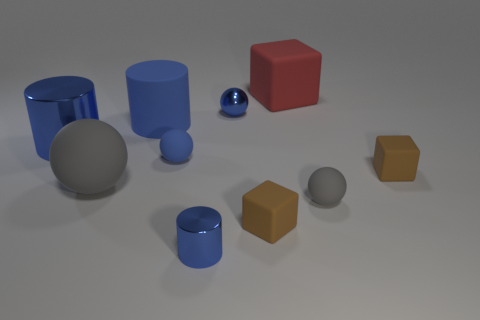Subtract all blue metallic cylinders. How many cylinders are left? 1 Subtract all gray spheres. How many spheres are left? 2 Subtract all yellow cylinders. Subtract all cyan cubes. How many cylinders are left? 3 Subtract all brown blocks. How many red cylinders are left? 0 Subtract all brown rubber things. Subtract all large blue cylinders. How many objects are left? 6 Add 4 small spheres. How many small spheres are left? 7 Add 2 spheres. How many spheres exist? 6 Subtract 0 brown cylinders. How many objects are left? 10 Subtract all cylinders. How many objects are left? 7 Subtract 2 cylinders. How many cylinders are left? 1 